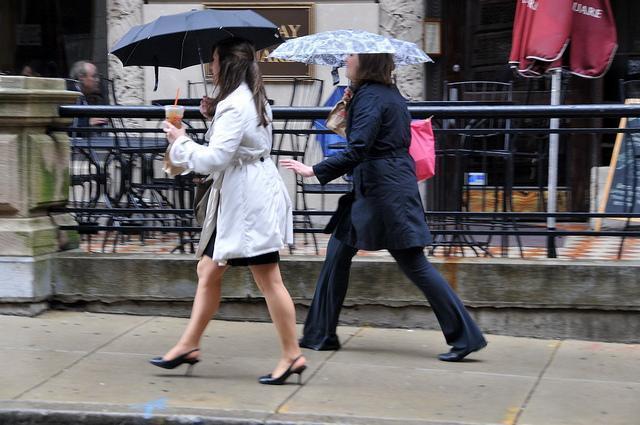How many umbrellas can be seen?
Give a very brief answer. 3. How many people are there?
Give a very brief answer. 2. How many chairs are there?
Give a very brief answer. 2. How many giraffes are laying down?
Give a very brief answer. 0. 